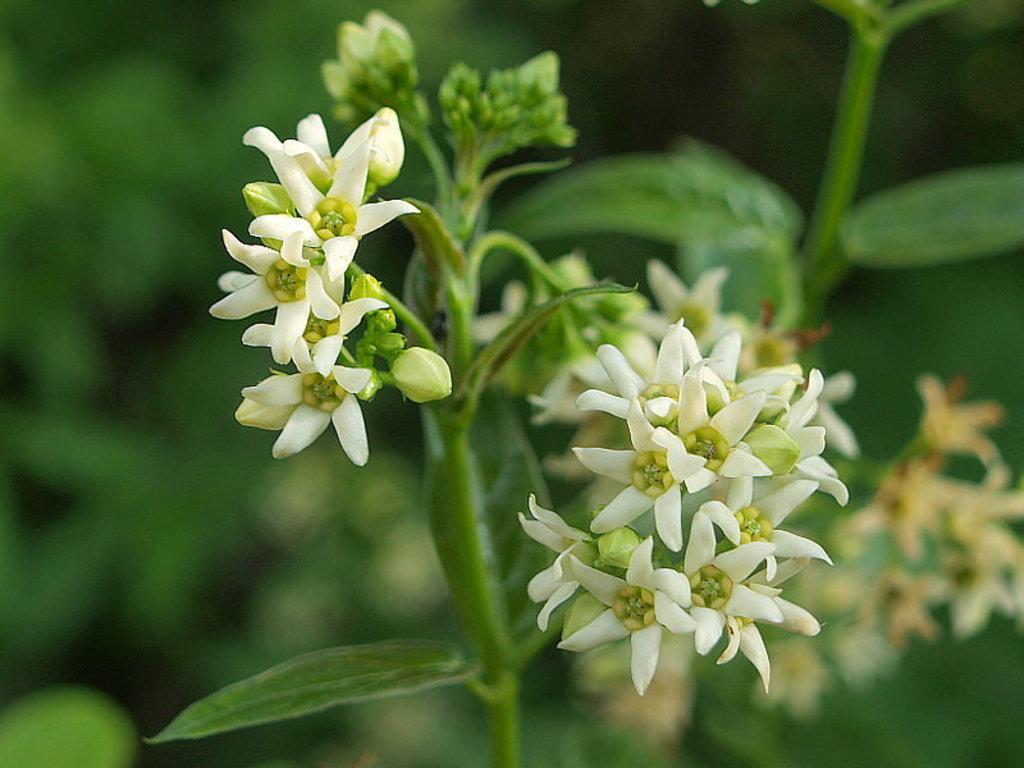How would you summarize this image in a sentence or two? In the center of the image there is a plant with flowers. The background of the image is blur. 